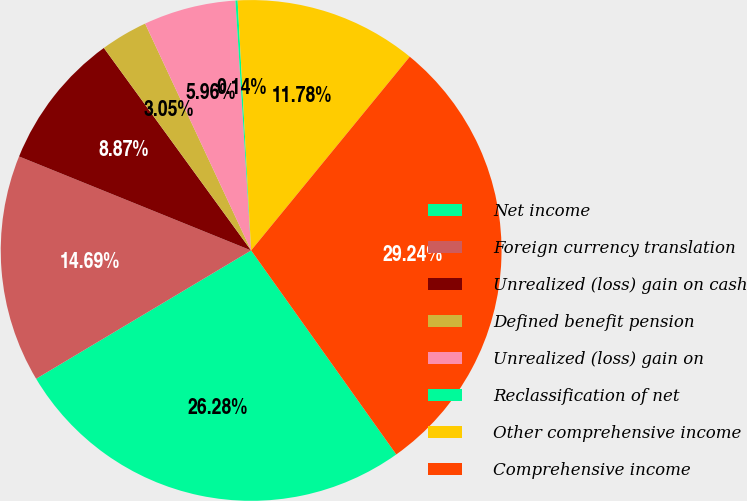Convert chart to OTSL. <chart><loc_0><loc_0><loc_500><loc_500><pie_chart><fcel>Net income<fcel>Foreign currency translation<fcel>Unrealized (loss) gain on cash<fcel>Defined benefit pension<fcel>Unrealized (loss) gain on<fcel>Reclassification of net<fcel>Other comprehensive income<fcel>Comprehensive income<nl><fcel>26.28%<fcel>14.69%<fcel>8.87%<fcel>3.05%<fcel>5.96%<fcel>0.14%<fcel>11.78%<fcel>29.24%<nl></chart> 